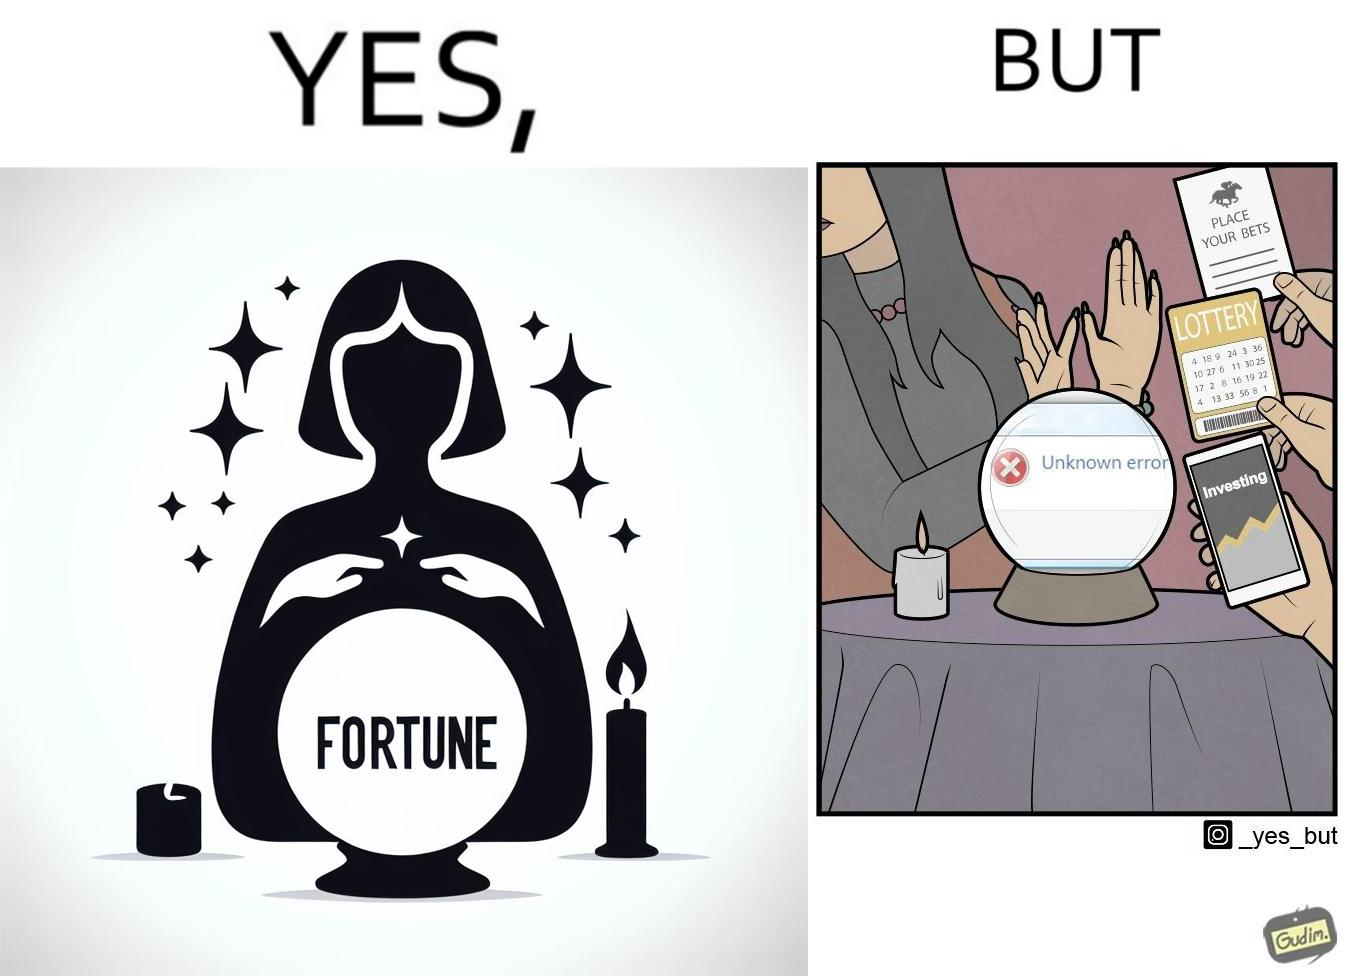Would you classify this image as satirical? Yes, this image is satirical. 